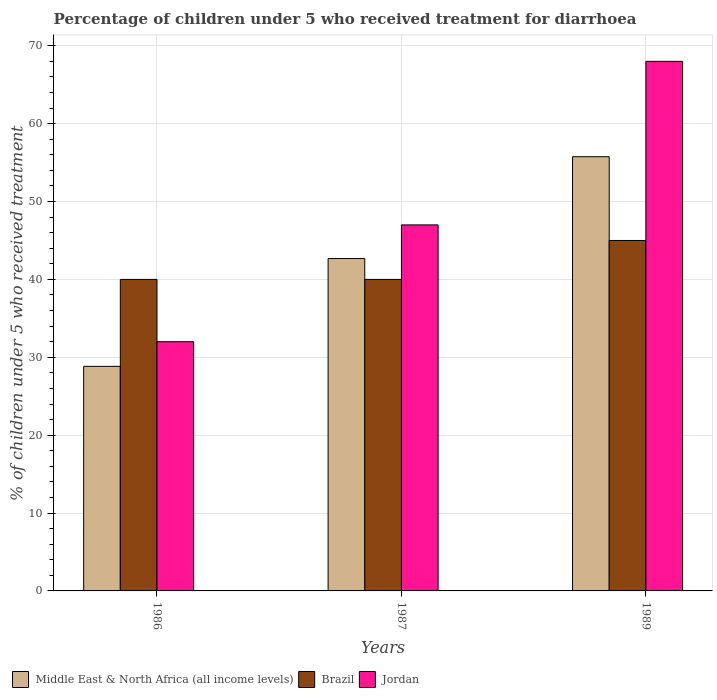Are the number of bars per tick equal to the number of legend labels?
Offer a terse response. Yes. How many bars are there on the 3rd tick from the left?
Offer a very short reply. 3. What is the label of the 2nd group of bars from the left?
Your answer should be very brief. 1987. What is the percentage of children who received treatment for diarrhoea  in Middle East & North Africa (all income levels) in 1989?
Give a very brief answer. 55.75. Across all years, what is the maximum percentage of children who received treatment for diarrhoea  in Jordan?
Offer a terse response. 68. Across all years, what is the minimum percentage of children who received treatment for diarrhoea  in Jordan?
Provide a succinct answer. 32. In which year was the percentage of children who received treatment for diarrhoea  in Jordan minimum?
Your answer should be compact. 1986. What is the total percentage of children who received treatment for diarrhoea  in Middle East & North Africa (all income levels) in the graph?
Give a very brief answer. 127.27. What is the difference between the percentage of children who received treatment for diarrhoea  in Middle East & North Africa (all income levels) in 1986 and that in 1987?
Your answer should be compact. -13.84. What is the difference between the percentage of children who received treatment for diarrhoea  in Middle East & North Africa (all income levels) in 1987 and the percentage of children who received treatment for diarrhoea  in Jordan in 1989?
Make the answer very short. -25.32. In the year 1989, what is the difference between the percentage of children who received treatment for diarrhoea  in Middle East & North Africa (all income levels) and percentage of children who received treatment for diarrhoea  in Jordan?
Your answer should be compact. -12.25. What is the ratio of the percentage of children who received treatment for diarrhoea  in Brazil in 1986 to that in 1987?
Make the answer very short. 1. Is the percentage of children who received treatment for diarrhoea  in Brazil in 1987 less than that in 1989?
Offer a very short reply. Yes. Is the difference between the percentage of children who received treatment for diarrhoea  in Middle East & North Africa (all income levels) in 1986 and 1987 greater than the difference between the percentage of children who received treatment for diarrhoea  in Jordan in 1986 and 1987?
Offer a very short reply. Yes. What is the difference between the highest and the lowest percentage of children who received treatment for diarrhoea  in Middle East & North Africa (all income levels)?
Give a very brief answer. 26.92. What does the 3rd bar from the left in 1987 represents?
Provide a succinct answer. Jordan. What does the 3rd bar from the right in 1986 represents?
Ensure brevity in your answer.  Middle East & North Africa (all income levels). Are all the bars in the graph horizontal?
Your answer should be compact. No. How many years are there in the graph?
Provide a short and direct response. 3. What is the difference between two consecutive major ticks on the Y-axis?
Your answer should be compact. 10. Are the values on the major ticks of Y-axis written in scientific E-notation?
Make the answer very short. No. Does the graph contain grids?
Provide a succinct answer. Yes. How many legend labels are there?
Ensure brevity in your answer.  3. How are the legend labels stacked?
Ensure brevity in your answer.  Horizontal. What is the title of the graph?
Offer a terse response. Percentage of children under 5 who received treatment for diarrhoea. What is the label or title of the X-axis?
Ensure brevity in your answer.  Years. What is the label or title of the Y-axis?
Make the answer very short. % of children under 5 who received treatment. What is the % of children under 5 who received treatment of Middle East & North Africa (all income levels) in 1986?
Ensure brevity in your answer.  28.84. What is the % of children under 5 who received treatment in Jordan in 1986?
Ensure brevity in your answer.  32. What is the % of children under 5 who received treatment in Middle East & North Africa (all income levels) in 1987?
Give a very brief answer. 42.68. What is the % of children under 5 who received treatment of Brazil in 1987?
Ensure brevity in your answer.  40. What is the % of children under 5 who received treatment of Jordan in 1987?
Provide a succinct answer. 47. What is the % of children under 5 who received treatment of Middle East & North Africa (all income levels) in 1989?
Offer a terse response. 55.75. Across all years, what is the maximum % of children under 5 who received treatment in Middle East & North Africa (all income levels)?
Provide a succinct answer. 55.75. Across all years, what is the maximum % of children under 5 who received treatment of Brazil?
Ensure brevity in your answer.  45. Across all years, what is the minimum % of children under 5 who received treatment in Middle East & North Africa (all income levels)?
Your answer should be compact. 28.84. Across all years, what is the minimum % of children under 5 who received treatment of Brazil?
Give a very brief answer. 40. Across all years, what is the minimum % of children under 5 who received treatment in Jordan?
Make the answer very short. 32. What is the total % of children under 5 who received treatment of Middle East & North Africa (all income levels) in the graph?
Ensure brevity in your answer.  127.27. What is the total % of children under 5 who received treatment of Brazil in the graph?
Your answer should be very brief. 125. What is the total % of children under 5 who received treatment in Jordan in the graph?
Offer a terse response. 147. What is the difference between the % of children under 5 who received treatment of Middle East & North Africa (all income levels) in 1986 and that in 1987?
Make the answer very short. -13.84. What is the difference between the % of children under 5 who received treatment of Jordan in 1986 and that in 1987?
Offer a very short reply. -15. What is the difference between the % of children under 5 who received treatment in Middle East & North Africa (all income levels) in 1986 and that in 1989?
Make the answer very short. -26.92. What is the difference between the % of children under 5 who received treatment of Brazil in 1986 and that in 1989?
Ensure brevity in your answer.  -5. What is the difference between the % of children under 5 who received treatment in Jordan in 1986 and that in 1989?
Offer a terse response. -36. What is the difference between the % of children under 5 who received treatment of Middle East & North Africa (all income levels) in 1987 and that in 1989?
Offer a very short reply. -13.07. What is the difference between the % of children under 5 who received treatment of Middle East & North Africa (all income levels) in 1986 and the % of children under 5 who received treatment of Brazil in 1987?
Offer a very short reply. -11.16. What is the difference between the % of children under 5 who received treatment of Middle East & North Africa (all income levels) in 1986 and the % of children under 5 who received treatment of Jordan in 1987?
Your response must be concise. -18.16. What is the difference between the % of children under 5 who received treatment of Middle East & North Africa (all income levels) in 1986 and the % of children under 5 who received treatment of Brazil in 1989?
Keep it short and to the point. -16.16. What is the difference between the % of children under 5 who received treatment of Middle East & North Africa (all income levels) in 1986 and the % of children under 5 who received treatment of Jordan in 1989?
Provide a succinct answer. -39.16. What is the difference between the % of children under 5 who received treatment of Brazil in 1986 and the % of children under 5 who received treatment of Jordan in 1989?
Offer a very short reply. -28. What is the difference between the % of children under 5 who received treatment in Middle East & North Africa (all income levels) in 1987 and the % of children under 5 who received treatment in Brazil in 1989?
Your answer should be compact. -2.32. What is the difference between the % of children under 5 who received treatment in Middle East & North Africa (all income levels) in 1987 and the % of children under 5 who received treatment in Jordan in 1989?
Give a very brief answer. -25.32. What is the difference between the % of children under 5 who received treatment of Brazil in 1987 and the % of children under 5 who received treatment of Jordan in 1989?
Ensure brevity in your answer.  -28. What is the average % of children under 5 who received treatment in Middle East & North Africa (all income levels) per year?
Give a very brief answer. 42.42. What is the average % of children under 5 who received treatment in Brazil per year?
Make the answer very short. 41.67. In the year 1986, what is the difference between the % of children under 5 who received treatment in Middle East & North Africa (all income levels) and % of children under 5 who received treatment in Brazil?
Your answer should be compact. -11.16. In the year 1986, what is the difference between the % of children under 5 who received treatment in Middle East & North Africa (all income levels) and % of children under 5 who received treatment in Jordan?
Offer a terse response. -3.16. In the year 1986, what is the difference between the % of children under 5 who received treatment of Brazil and % of children under 5 who received treatment of Jordan?
Provide a succinct answer. 8. In the year 1987, what is the difference between the % of children under 5 who received treatment in Middle East & North Africa (all income levels) and % of children under 5 who received treatment in Brazil?
Give a very brief answer. 2.68. In the year 1987, what is the difference between the % of children under 5 who received treatment of Middle East & North Africa (all income levels) and % of children under 5 who received treatment of Jordan?
Provide a succinct answer. -4.32. In the year 1987, what is the difference between the % of children under 5 who received treatment of Brazil and % of children under 5 who received treatment of Jordan?
Ensure brevity in your answer.  -7. In the year 1989, what is the difference between the % of children under 5 who received treatment of Middle East & North Africa (all income levels) and % of children under 5 who received treatment of Brazil?
Your answer should be compact. 10.75. In the year 1989, what is the difference between the % of children under 5 who received treatment in Middle East & North Africa (all income levels) and % of children under 5 who received treatment in Jordan?
Your answer should be very brief. -12.25. What is the ratio of the % of children under 5 who received treatment in Middle East & North Africa (all income levels) in 1986 to that in 1987?
Your answer should be very brief. 0.68. What is the ratio of the % of children under 5 who received treatment in Jordan in 1986 to that in 1987?
Your answer should be very brief. 0.68. What is the ratio of the % of children under 5 who received treatment in Middle East & North Africa (all income levels) in 1986 to that in 1989?
Keep it short and to the point. 0.52. What is the ratio of the % of children under 5 who received treatment of Brazil in 1986 to that in 1989?
Offer a very short reply. 0.89. What is the ratio of the % of children under 5 who received treatment of Jordan in 1986 to that in 1989?
Keep it short and to the point. 0.47. What is the ratio of the % of children under 5 who received treatment of Middle East & North Africa (all income levels) in 1987 to that in 1989?
Your answer should be very brief. 0.77. What is the ratio of the % of children under 5 who received treatment in Brazil in 1987 to that in 1989?
Make the answer very short. 0.89. What is the ratio of the % of children under 5 who received treatment in Jordan in 1987 to that in 1989?
Your answer should be compact. 0.69. What is the difference between the highest and the second highest % of children under 5 who received treatment of Middle East & North Africa (all income levels)?
Offer a terse response. 13.07. What is the difference between the highest and the second highest % of children under 5 who received treatment in Brazil?
Offer a terse response. 5. What is the difference between the highest and the lowest % of children under 5 who received treatment of Middle East & North Africa (all income levels)?
Your answer should be compact. 26.92. What is the difference between the highest and the lowest % of children under 5 who received treatment of Brazil?
Your answer should be compact. 5. What is the difference between the highest and the lowest % of children under 5 who received treatment of Jordan?
Provide a succinct answer. 36. 